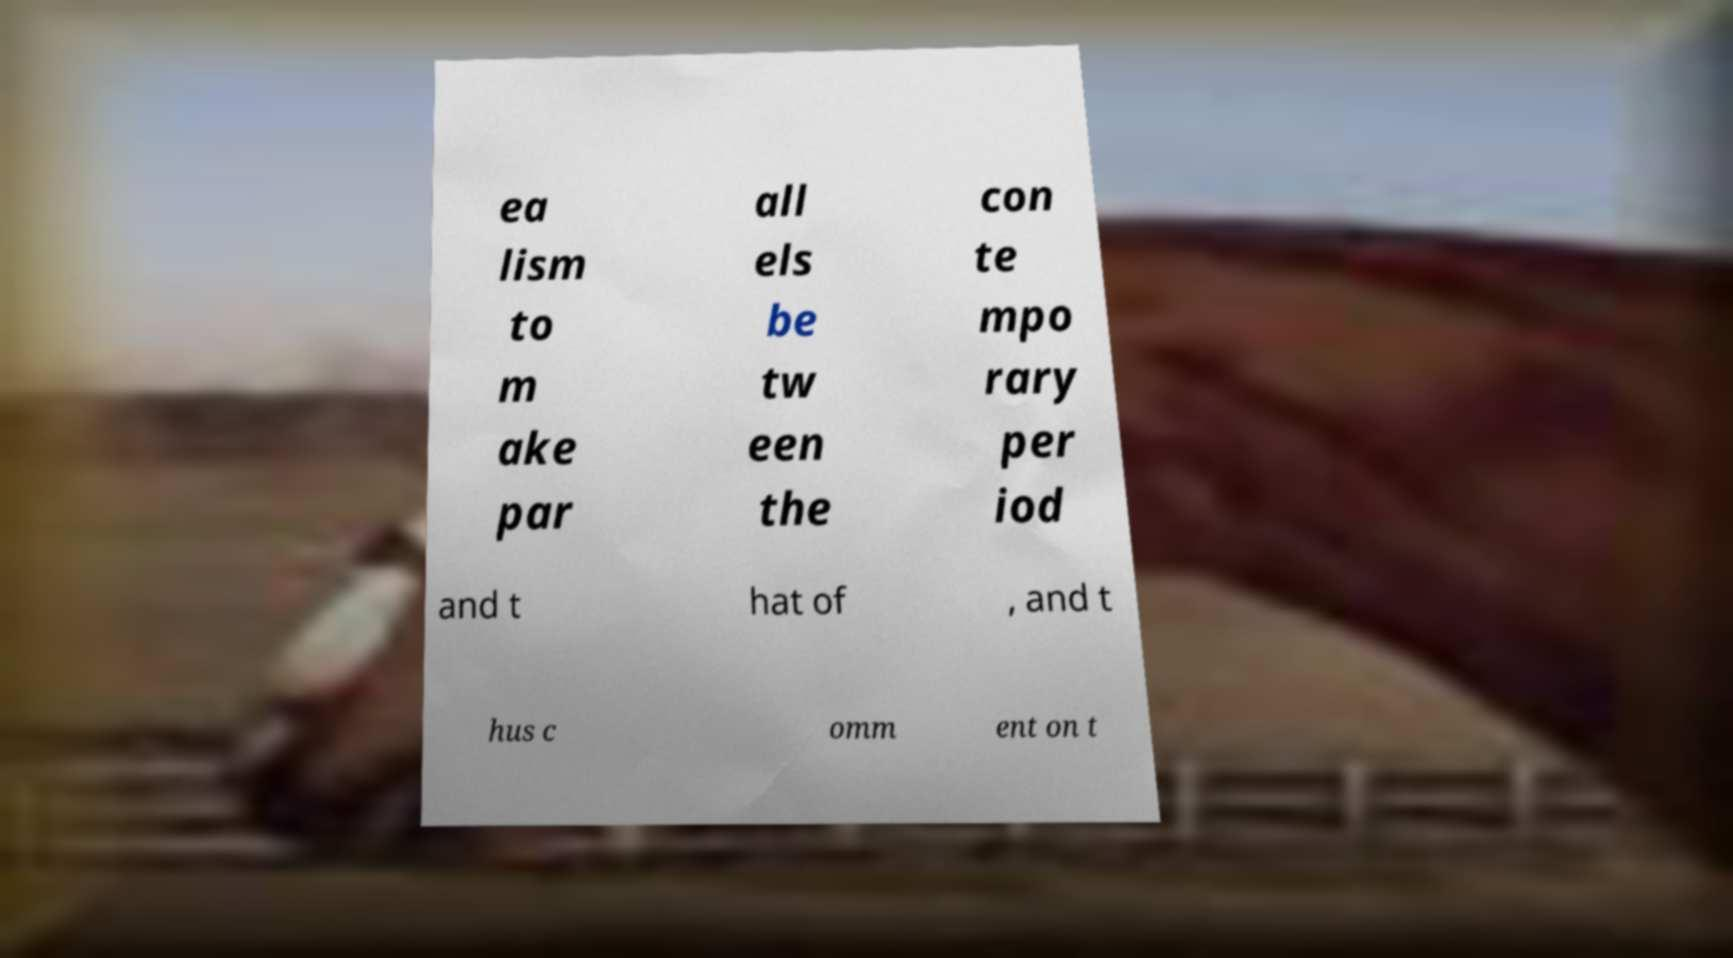Could you assist in decoding the text presented in this image and type it out clearly? ea lism to m ake par all els be tw een the con te mpo rary per iod and t hat of , and t hus c omm ent on t 